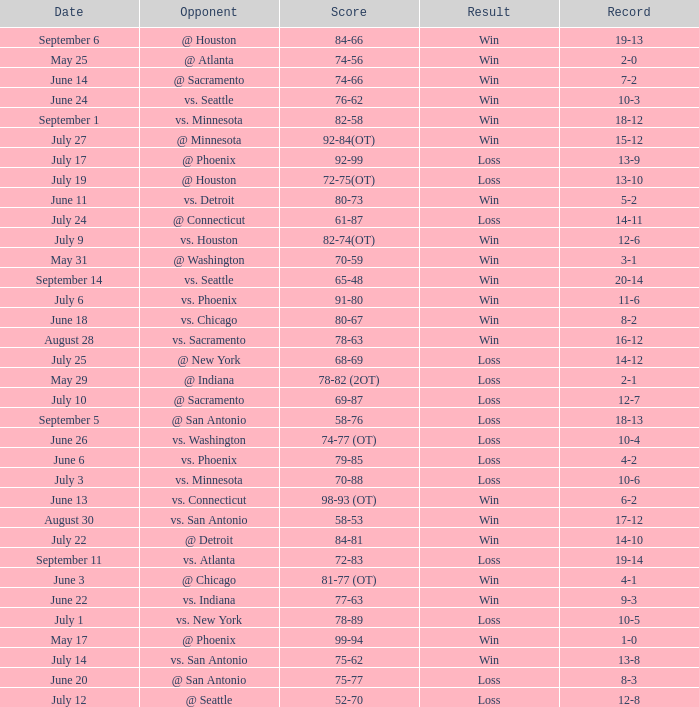What is the Record of the game on September 6? 19-13. 